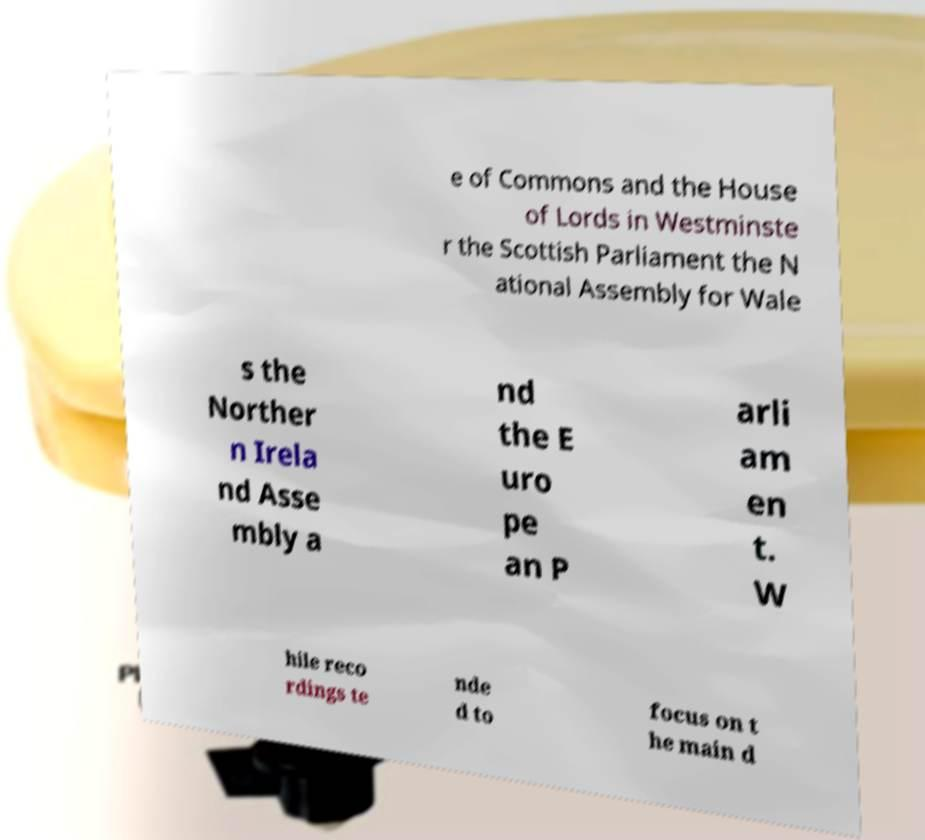For documentation purposes, I need the text within this image transcribed. Could you provide that? e of Commons and the House of Lords in Westminste r the Scottish Parliament the N ational Assembly for Wale s the Norther n Irela nd Asse mbly a nd the E uro pe an P arli am en t. W hile reco rdings te nde d to focus on t he main d 